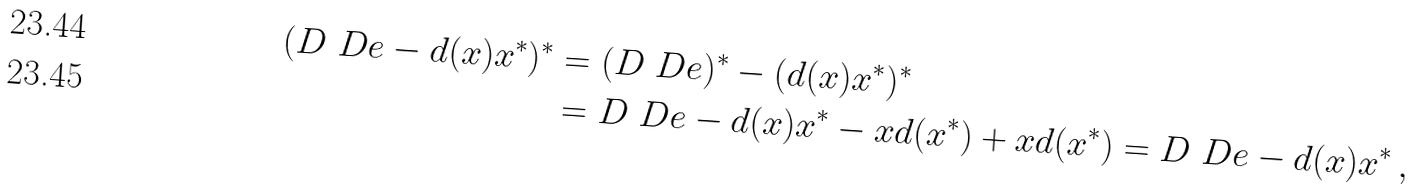Convert formula to latex. <formula><loc_0><loc_0><loc_500><loc_500>( D \ D e - d ( x ) x ^ { * } ) ^ { * } & = ( D \ D e ) ^ { * } - ( d ( x ) x ^ { * } ) ^ { * } \\ & = D \ D e - d ( x ) x ^ { * } - x d ( x ^ { * } ) + x d ( x ^ { * } ) = D \ D e - d ( x ) x ^ { * } \, ,</formula> 